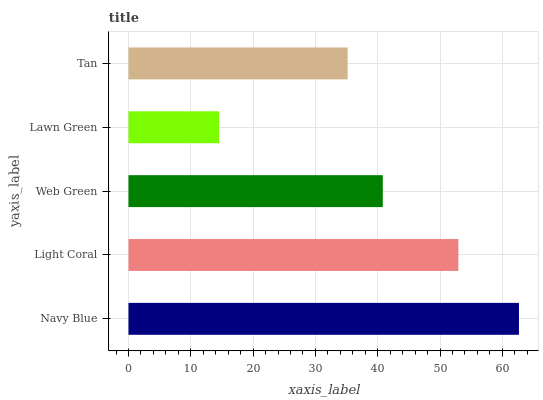Is Lawn Green the minimum?
Answer yes or no. Yes. Is Navy Blue the maximum?
Answer yes or no. Yes. Is Light Coral the minimum?
Answer yes or no. No. Is Light Coral the maximum?
Answer yes or no. No. Is Navy Blue greater than Light Coral?
Answer yes or no. Yes. Is Light Coral less than Navy Blue?
Answer yes or no. Yes. Is Light Coral greater than Navy Blue?
Answer yes or no. No. Is Navy Blue less than Light Coral?
Answer yes or no. No. Is Web Green the high median?
Answer yes or no. Yes. Is Web Green the low median?
Answer yes or no. Yes. Is Lawn Green the high median?
Answer yes or no. No. Is Lawn Green the low median?
Answer yes or no. No. 